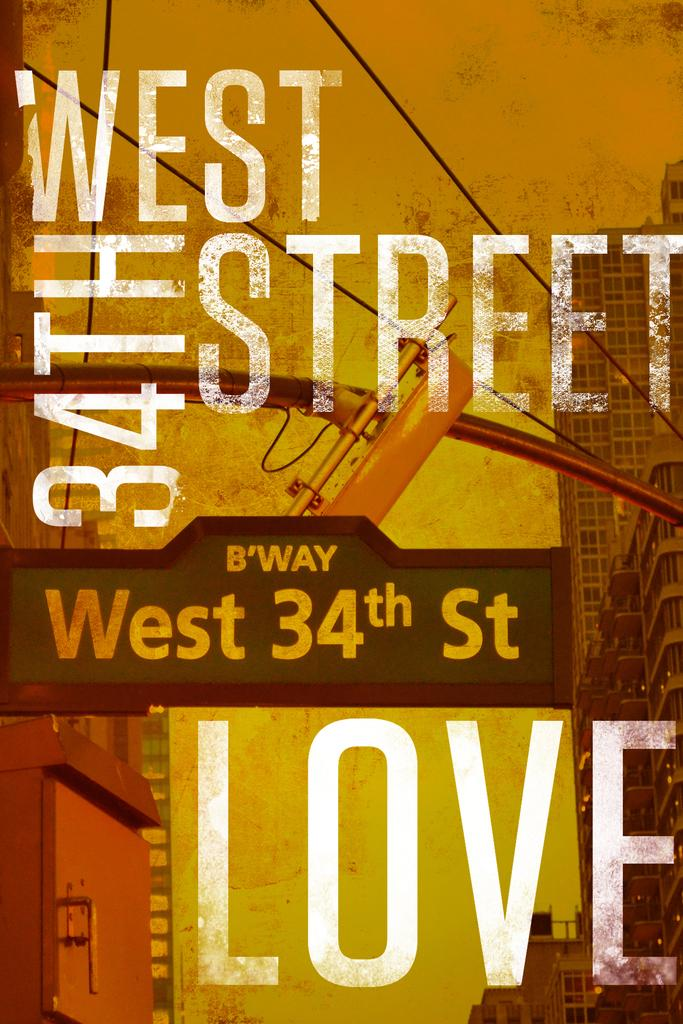<image>
Create a compact narrative representing the image presented. a poster that says 'west 34th street' at the top of it 